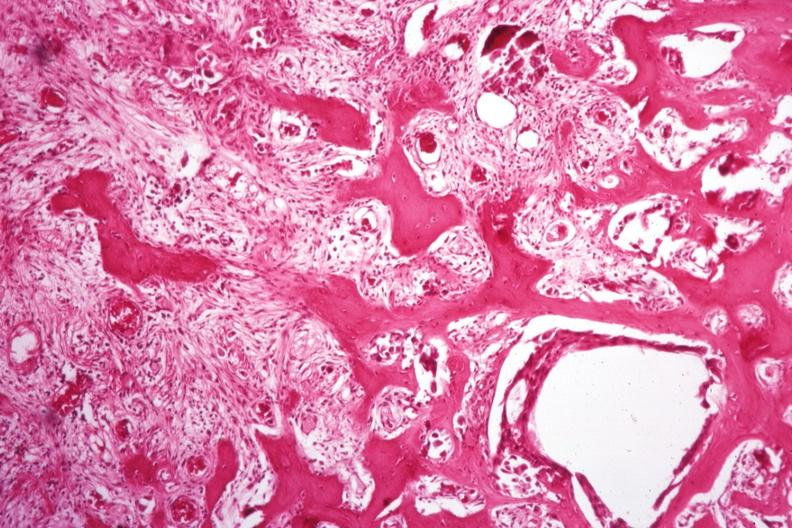what does this image show?
Answer the question using a single word or phrase. Nice new bone formation tumor difficult to see 